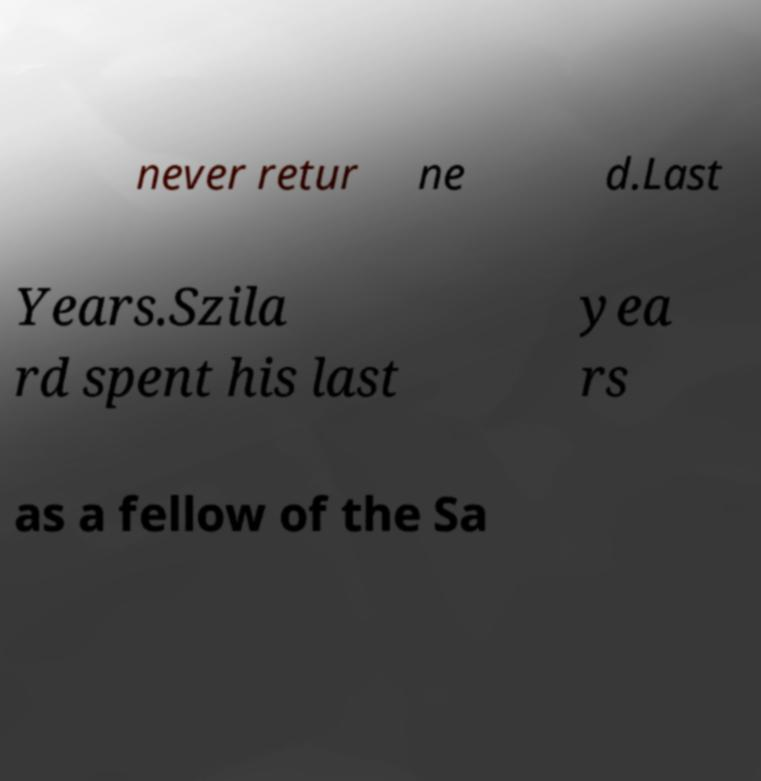For documentation purposes, I need the text within this image transcribed. Could you provide that? never retur ne d.Last Years.Szila rd spent his last yea rs as a fellow of the Sa 